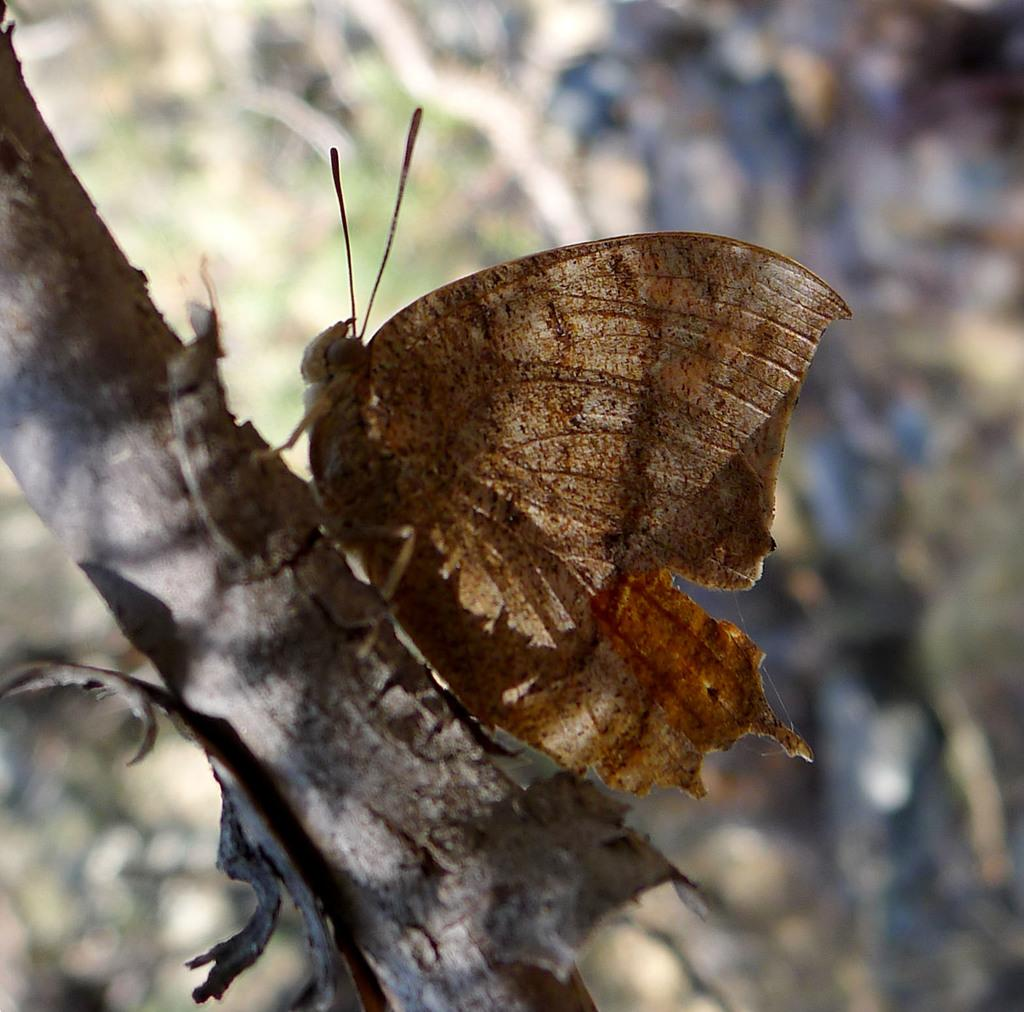What is the main subject of the image? There is a butterfly in the image. Where is the butterfly located? The butterfly is on the branch of a tree. What type of operation is being performed on the butterfly in the image? There is no operation being performed on the butterfly in the image; it is simply resting on the branch of a tree. 